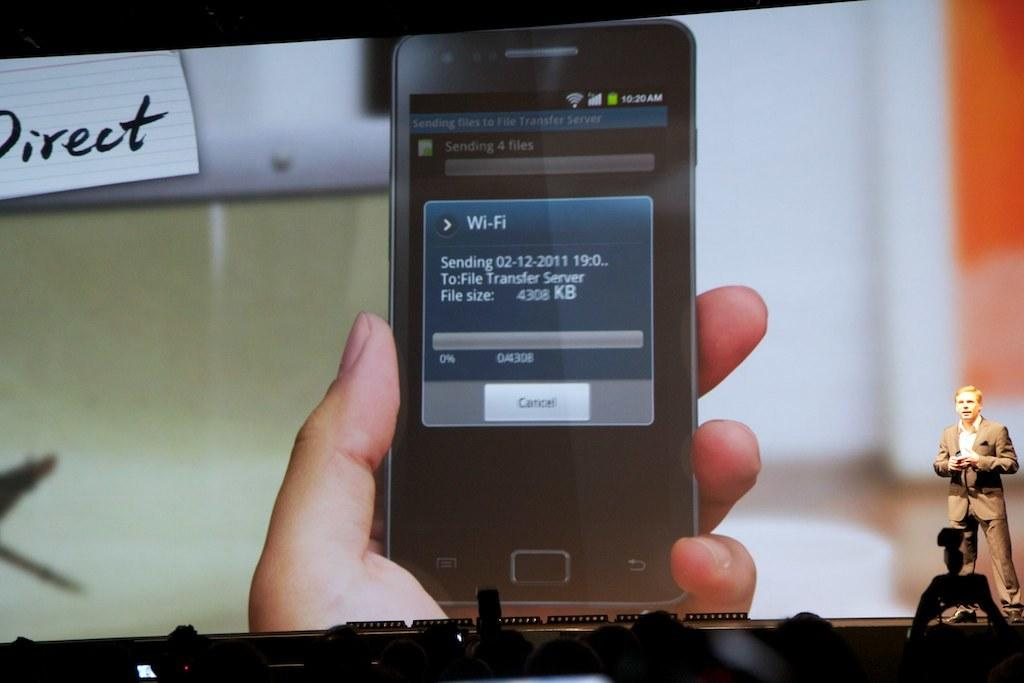<image>
Render a clear and concise summary of the photo. A phone screen is open to a Wi-Fi screen, which is sending a file. 